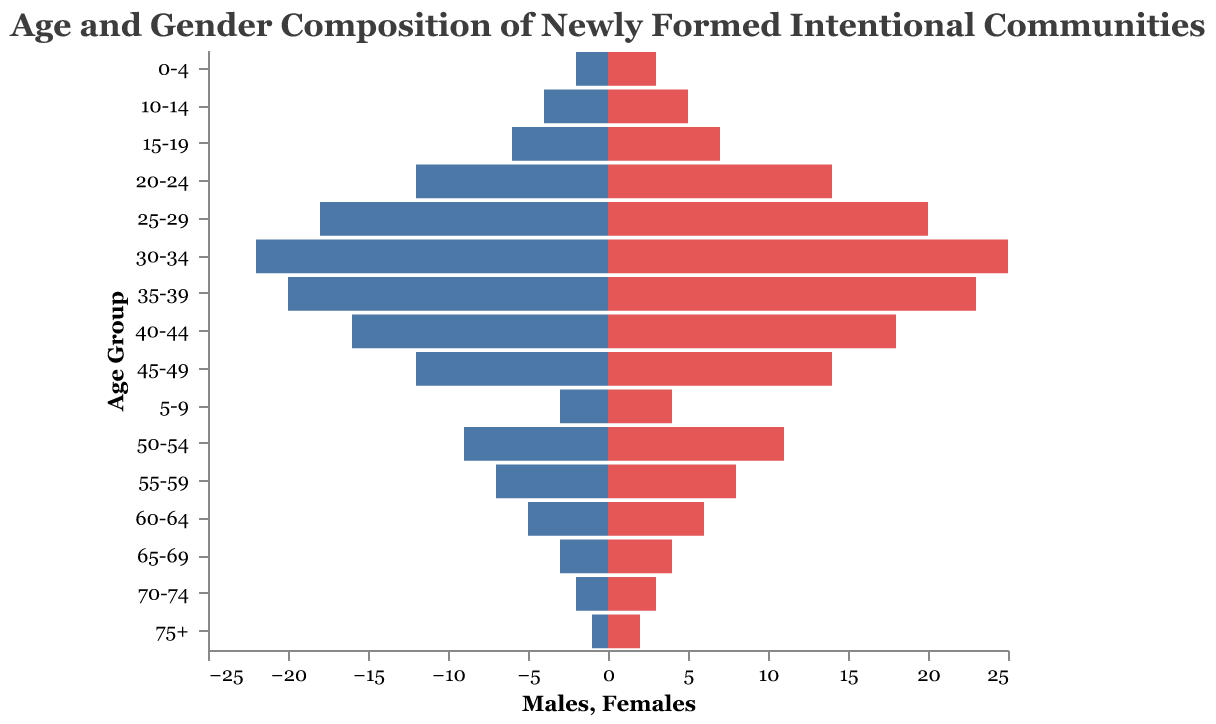What is the title of the figure? The title is clearly written at the top of the figure.
Answer: Age and Gender Composition of Newly Formed Intentional Communities How many age groups are represented in the population pyramid? Count the distinct age groups listed on the Y-axis.
Answer: 16 What is the age group with the highest number of males? Look at the bars on the left side for the age group with the widest extent.
Answer: 30-34 What is the total number of females in the 25-29 and 30-34 age groups combined? Sum the number of females in both age groups: 20 (25-29) + 25 (30-34).
Answer: 45 How many more males are there in the 30-34 age group compared to the 15-19 age group? Subtract the number of males in the 15-19 age group from the 30-34 age group: 22 (30-34) - 6 (15-19).
Answer: 16 Which age group has an equal number of males and females? Check the age groups where the lengths of the blue and red bars are equal.
Answer: No age group How does the male population in the 20-24 age group compare to the female population in the same age group? Compare the lengths of the blue and red bars for the 20-24 age group.
Answer: Females have a higher number than males What is the difference in the number of females between the youngest (0-4) and oldest (75+) age groups? Subtract the number of females in the 75+ age group from the 0-4 age group: 3 (0-4) - 2 (75+).
Answer: 1 What percentage of the total male population is represented by the 35-39 age group? Calculate the total male population and then divide the number of males in the 35-39 age group by this total, then multiply by 100. The total male population is the sum of all male numbers: 2+3+4+6+12+18+22+20+16+12+9+7+5+3+2+1=142. The percentage for 35-39 is (20/142)*100.
Answer: 14.08% Which gender has more individuals in the 50-54 age group and by how much? Compare the number of males and females in the 50-54 age group and subtract the smaller number from the larger number: 11 (females) - 9 (males).
Answer: Females by 2 